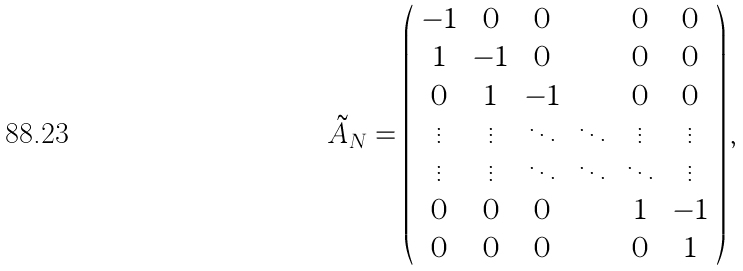<formula> <loc_0><loc_0><loc_500><loc_500>\tilde { A } _ { N } = \left ( \begin{array} { c c c c c c } - 1 & 0 & 0 & \cdots & 0 & 0 \\ 1 & - 1 & 0 & \cdots & 0 & 0 \\ 0 & 1 & - 1 & \cdots & 0 & 0 \\ \vdots & \vdots & \ddots & \ddots & \vdots & \vdots \\ \vdots & \vdots & \ddots & \ddots & \ddots & \vdots \\ 0 & 0 & 0 & \cdots & 1 & - 1 \\ 0 & 0 & 0 & \cdots & 0 & 1 \end{array} \right ) ,</formula> 